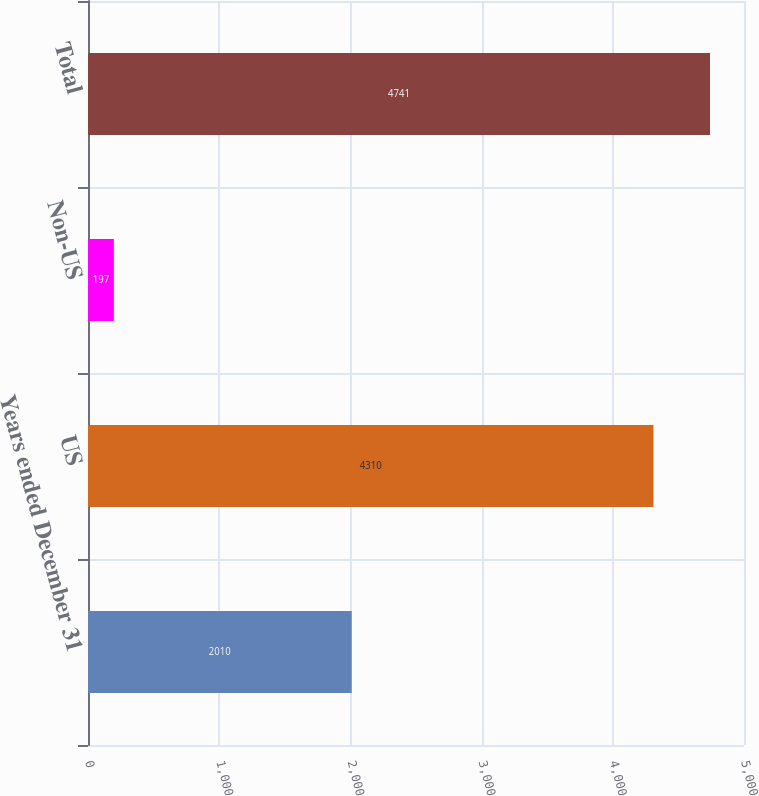Convert chart. <chart><loc_0><loc_0><loc_500><loc_500><bar_chart><fcel>Years ended December 31<fcel>US<fcel>Non-US<fcel>Total<nl><fcel>2010<fcel>4310<fcel>197<fcel>4741<nl></chart> 